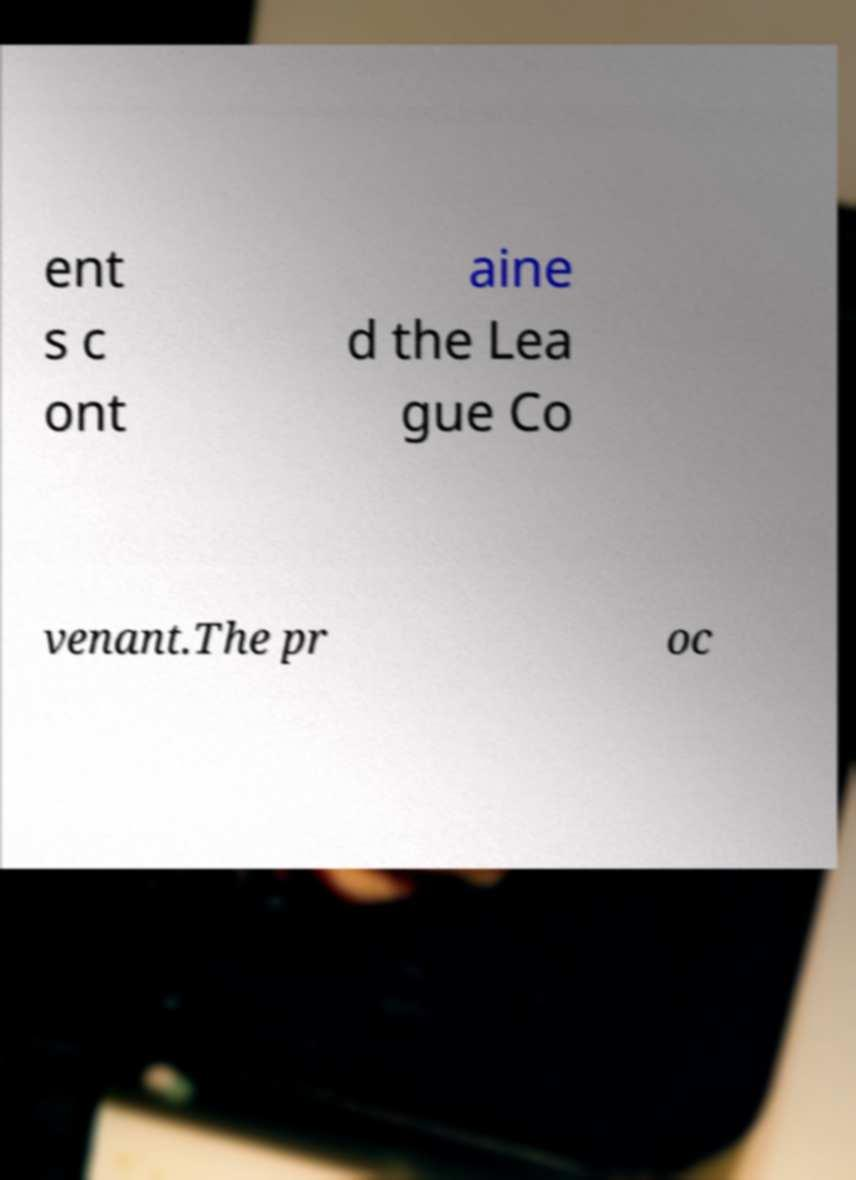Please read and relay the text visible in this image. What does it say? ent s c ont aine d the Lea gue Co venant.The pr oc 